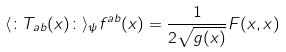Convert formula to latex. <formula><loc_0><loc_0><loc_500><loc_500>\langle { \colon } T _ { a b } ( x ) { \colon } \rangle _ { \psi } f ^ { a b } ( x ) = \frac { 1 } { 2 \sqrt { g ( x ) } } F ( x , x )</formula> 